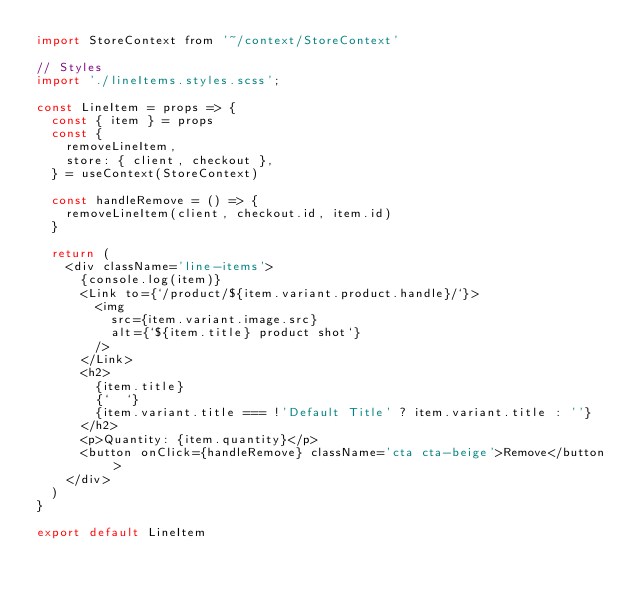<code> <loc_0><loc_0><loc_500><loc_500><_JavaScript_>import StoreContext from '~/context/StoreContext'

// Styles
import './lineItems.styles.scss';

const LineItem = props => {
  const { item } = props
  const {
    removeLineItem,
    store: { client, checkout },
  } = useContext(StoreContext)

  const handleRemove = () => {
    removeLineItem(client, checkout.id, item.id)
  }

  return (
    <div className='line-items'>
      {console.log(item)}
      <Link to={`/product/${item.variant.product.handle}/`}>
        <img
          src={item.variant.image.src}
          alt={`${item.title} product shot`}
        />
      </Link>
      <h2>
        {item.title}
        {`  `}
        {item.variant.title === !'Default Title' ? item.variant.title : ''}
      </h2>
      <p>Quantity: {item.quantity}</p>
      <button onClick={handleRemove} className='cta cta-beige'>Remove</button>
    </div>
  )
}

export default LineItem
</code> 